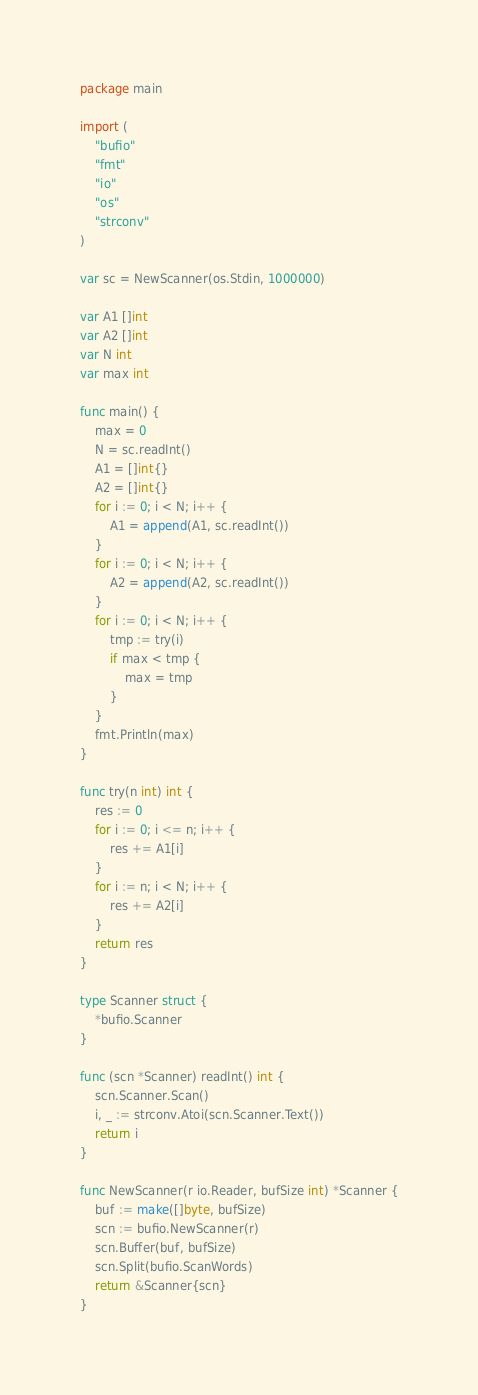<code> <loc_0><loc_0><loc_500><loc_500><_Go_>package main

import (
	"bufio"
	"fmt"
	"io"
	"os"
	"strconv"
)

var sc = NewScanner(os.Stdin, 1000000)

var A1 []int
var A2 []int
var N int
var max int

func main() {
	max = 0
	N = sc.readInt()
	A1 = []int{}
	A2 = []int{}
	for i := 0; i < N; i++ {
		A1 = append(A1, sc.readInt())
	}
	for i := 0; i < N; i++ {
		A2 = append(A2, sc.readInt())
	}
	for i := 0; i < N; i++ {
		tmp := try(i)
		if max < tmp {
			max = tmp
		}
	}
	fmt.Println(max)
}

func try(n int) int {
	res := 0
	for i := 0; i <= n; i++ {
		res += A1[i]
	}
	for i := n; i < N; i++ {
		res += A2[i]
	}
	return res
}

type Scanner struct {
	*bufio.Scanner
}

func (scn *Scanner) readInt() int {
	scn.Scanner.Scan()
	i, _ := strconv.Atoi(scn.Scanner.Text())
	return i
}

func NewScanner(r io.Reader, bufSize int) *Scanner {
	buf := make([]byte, bufSize)
	scn := bufio.NewScanner(r)
	scn.Buffer(buf, bufSize)
	scn.Split(bufio.ScanWords)
	return &Scanner{scn}
}
</code> 